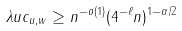Convert formula to latex. <formula><loc_0><loc_0><loc_500><loc_500>\lambda u c _ { u , w } \geq n ^ { - o ( 1 ) } ( 4 ^ { - \ell } n ) ^ { 1 - \alpha / 2 }</formula> 